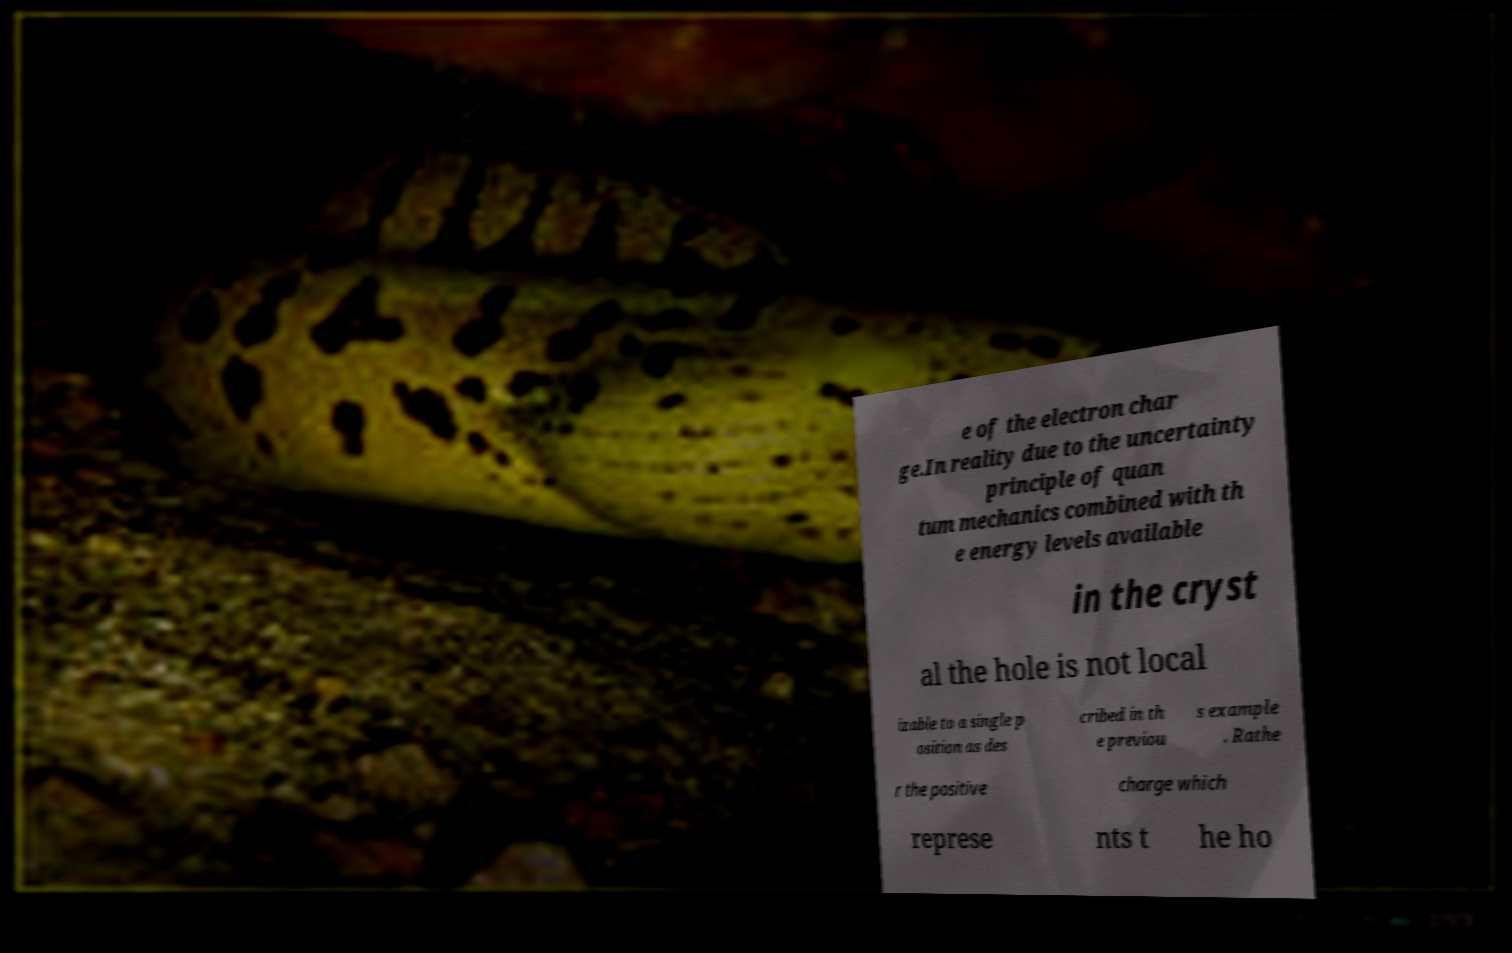There's text embedded in this image that I need extracted. Can you transcribe it verbatim? e of the electron char ge.In reality due to the uncertainty principle of quan tum mechanics combined with th e energy levels available in the cryst al the hole is not local izable to a single p osition as des cribed in th e previou s example . Rathe r the positive charge which represe nts t he ho 